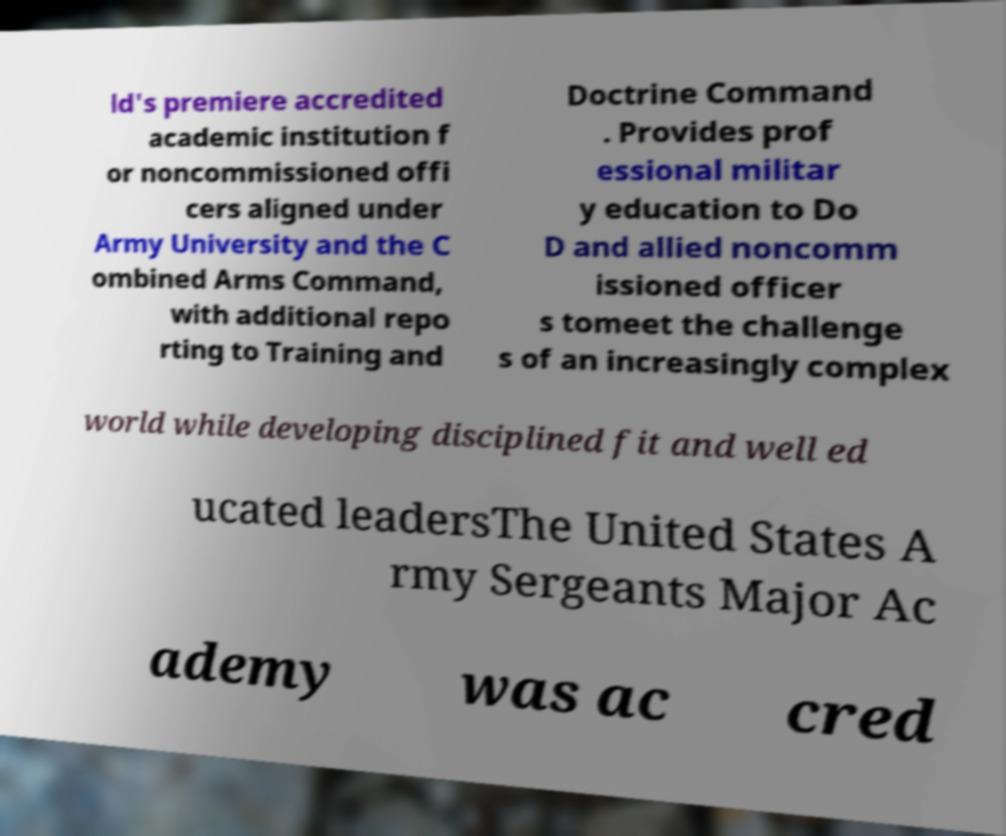Could you assist in decoding the text presented in this image and type it out clearly? ld's premiere accredited academic institution f or noncommissioned offi cers aligned under Army University and the C ombined Arms Command, with additional repo rting to Training and Doctrine Command . Provides prof essional militar y education to Do D and allied noncomm issioned officer s tomeet the challenge s of an increasingly complex world while developing disciplined fit and well ed ucated leadersThe United States A rmy Sergeants Major Ac ademy was ac cred 